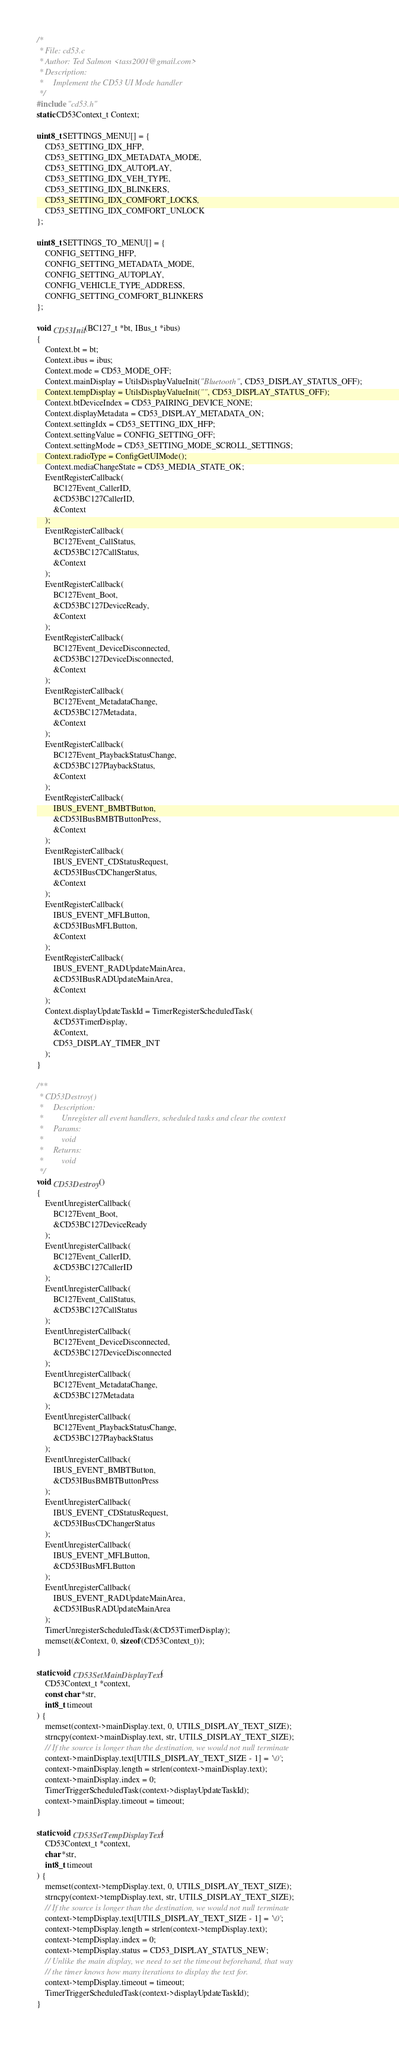<code> <loc_0><loc_0><loc_500><loc_500><_C_>/*
 * File: cd53.c
 * Author: Ted Salmon <tass2001@gmail.com>
 * Description:
 *     Implement the CD53 UI Mode handler
 */
#include "cd53.h"
static CD53Context_t Context;

uint8_t SETTINGS_MENU[] = {
    CD53_SETTING_IDX_HFP,
    CD53_SETTING_IDX_METADATA_MODE,
    CD53_SETTING_IDX_AUTOPLAY,
    CD53_SETTING_IDX_VEH_TYPE,
    CD53_SETTING_IDX_BLINKERS,
    CD53_SETTING_IDX_COMFORT_LOCKS,
    CD53_SETTING_IDX_COMFORT_UNLOCK
};

uint8_t SETTINGS_TO_MENU[] = {
    CONFIG_SETTING_HFP,
    CONFIG_SETTING_METADATA_MODE,
    CONFIG_SETTING_AUTOPLAY,
    CONFIG_VEHICLE_TYPE_ADDRESS,
    CONFIG_SETTING_COMFORT_BLINKERS
};

void CD53Init(BC127_t *bt, IBus_t *ibus)
{
    Context.bt = bt;
    Context.ibus = ibus;
    Context.mode = CD53_MODE_OFF;
    Context.mainDisplay = UtilsDisplayValueInit("Bluetooth", CD53_DISPLAY_STATUS_OFF);
    Context.tempDisplay = UtilsDisplayValueInit("", CD53_DISPLAY_STATUS_OFF);
    Context.btDeviceIndex = CD53_PAIRING_DEVICE_NONE;
    Context.displayMetadata = CD53_DISPLAY_METADATA_ON;
    Context.settingIdx = CD53_SETTING_IDX_HFP;
    Context.settingValue = CONFIG_SETTING_OFF;
    Context.settingMode = CD53_SETTING_MODE_SCROLL_SETTINGS;
    Context.radioType = ConfigGetUIMode();
    Context.mediaChangeState = CD53_MEDIA_STATE_OK;
    EventRegisterCallback(
        BC127Event_CallerID,
        &CD53BC127CallerID,
        &Context
    );
    EventRegisterCallback(
        BC127Event_CallStatus,
        &CD53BC127CallStatus,
        &Context
    );
    EventRegisterCallback(
        BC127Event_Boot,
        &CD53BC127DeviceReady,
        &Context
    );
    EventRegisterCallback(
        BC127Event_DeviceDisconnected,
        &CD53BC127DeviceDisconnected,
        &Context
    );
    EventRegisterCallback(
        BC127Event_MetadataChange,
        &CD53BC127Metadata,
        &Context
    );
    EventRegisterCallback(
        BC127Event_PlaybackStatusChange,
        &CD53BC127PlaybackStatus,
        &Context
    );
    EventRegisterCallback(
        IBUS_EVENT_BMBTButton,
        &CD53IBusBMBTButtonPress,
        &Context
    );
    EventRegisterCallback(
        IBUS_EVENT_CDStatusRequest,
        &CD53IBusCDChangerStatus,
        &Context
    );
    EventRegisterCallback(
        IBUS_EVENT_MFLButton,
        &CD53IBusMFLButton,
        &Context
    );
    EventRegisterCallback(
        IBUS_EVENT_RADUpdateMainArea,
        &CD53IBusRADUpdateMainArea,
        &Context
    );
    Context.displayUpdateTaskId = TimerRegisterScheduledTask(
        &CD53TimerDisplay,
        &Context,
        CD53_DISPLAY_TIMER_INT
    );
}

/**
 * CD53Destroy()
 *     Description:
 *         Unregister all event handlers, scheduled tasks and clear the context
 *     Params:
 *         void
 *     Returns:
 *         void
 */
void CD53Destroy()
{
    EventUnregisterCallback(
        BC127Event_Boot,
        &CD53BC127DeviceReady
    );
    EventUnregisterCallback(
        BC127Event_CallerID,
        &CD53BC127CallerID
    );
    EventUnregisterCallback(
        BC127Event_CallStatus,
        &CD53BC127CallStatus
    );
    EventUnregisterCallback(
        BC127Event_DeviceDisconnected,
        &CD53BC127DeviceDisconnected
    );
    EventUnregisterCallback(
        BC127Event_MetadataChange,
        &CD53BC127Metadata
    );
    EventUnregisterCallback(
        BC127Event_PlaybackStatusChange,
        &CD53BC127PlaybackStatus
    );
    EventUnregisterCallback(
        IBUS_EVENT_BMBTButton,
        &CD53IBusBMBTButtonPress
    );
    EventUnregisterCallback(
        IBUS_EVENT_CDStatusRequest,
        &CD53IBusCDChangerStatus
    );
    EventUnregisterCallback(
        IBUS_EVENT_MFLButton,
        &CD53IBusMFLButton
    );
    EventUnregisterCallback(
        IBUS_EVENT_RADUpdateMainArea,
        &CD53IBusRADUpdateMainArea
    );
    TimerUnregisterScheduledTask(&CD53TimerDisplay);
    memset(&Context, 0, sizeof(CD53Context_t));
}

static void CD53SetMainDisplayText(
    CD53Context_t *context,
    const char *str,
    int8_t timeout
) {
    memset(context->mainDisplay.text, 0, UTILS_DISPLAY_TEXT_SIZE);
    strncpy(context->mainDisplay.text, str, UTILS_DISPLAY_TEXT_SIZE);
    // If the source is longer than the destination, we would not null terminate
    context->mainDisplay.text[UTILS_DISPLAY_TEXT_SIZE - 1] = '\0';
    context->mainDisplay.length = strlen(context->mainDisplay.text);
    context->mainDisplay.index = 0;
    TimerTriggerScheduledTask(context->displayUpdateTaskId);
    context->mainDisplay.timeout = timeout;
}

static void CD53SetTempDisplayText(
    CD53Context_t *context,
    char *str,
    int8_t timeout
) {
    memset(context->tempDisplay.text, 0, UTILS_DISPLAY_TEXT_SIZE);
    strncpy(context->tempDisplay.text, str, UTILS_DISPLAY_TEXT_SIZE);
    // If the source is longer than the destination, we would not null terminate
    context->tempDisplay.text[UTILS_DISPLAY_TEXT_SIZE - 1] = '\0';
    context->tempDisplay.length = strlen(context->tempDisplay.text);
    context->tempDisplay.index = 0;
    context->tempDisplay.status = CD53_DISPLAY_STATUS_NEW;
    // Unlike the main display, we need to set the timeout beforehand, that way
    // the timer knows how many iterations to display the text for.
    context->tempDisplay.timeout = timeout;
    TimerTriggerScheduledTask(context->displayUpdateTaskId);
}
</code> 